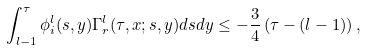<formula> <loc_0><loc_0><loc_500><loc_500>\int _ { l - 1 } ^ { \tau } \phi ^ { l } _ { i } ( s , y ) \Gamma ^ { l } _ { r } ( \tau , x ; s , y ) d s d y \leq - \frac { 3 } { 4 } \left ( \tau - ( l - 1 ) \right ) ,</formula> 